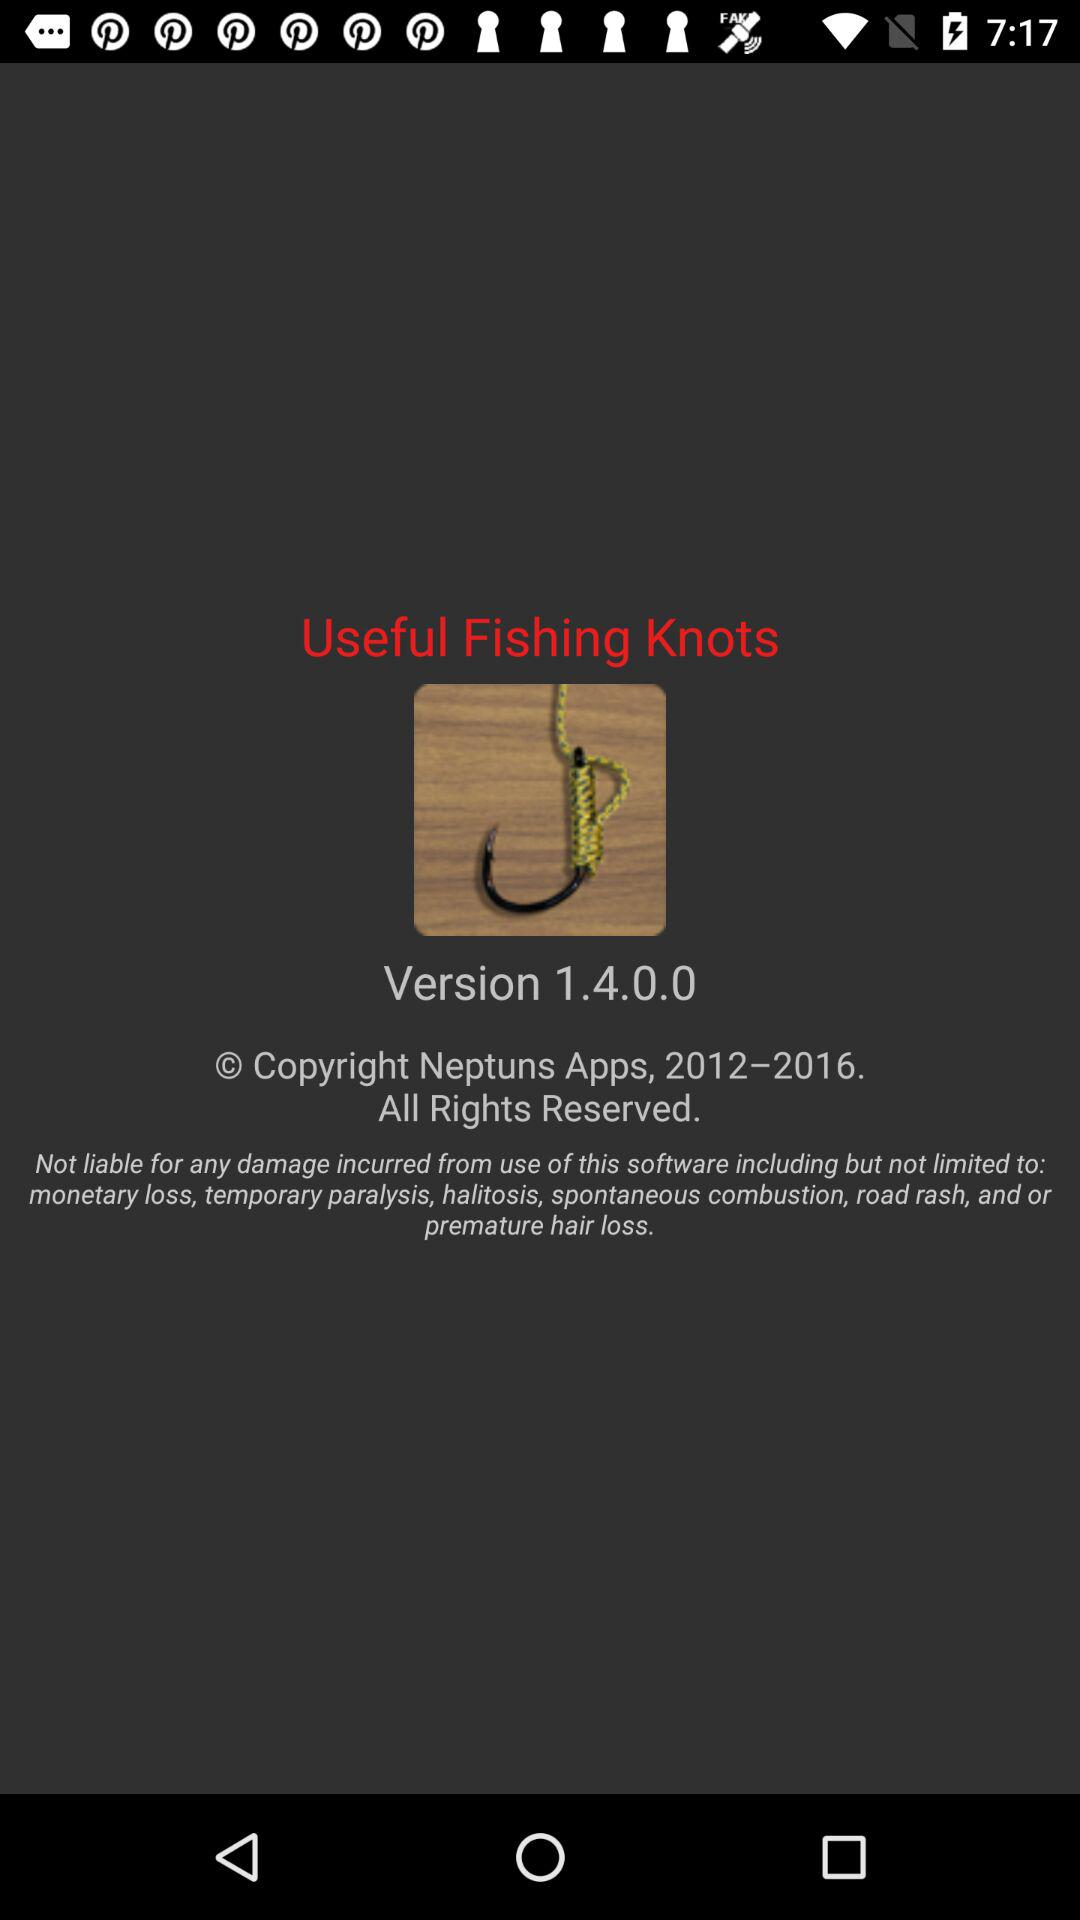What type of knot is used? The type of knot used is "Useful Fishing Knots". 